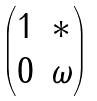Convert formula to latex. <formula><loc_0><loc_0><loc_500><loc_500>\begin{pmatrix} 1 & \ast \\ 0 & \omega \end{pmatrix}</formula> 